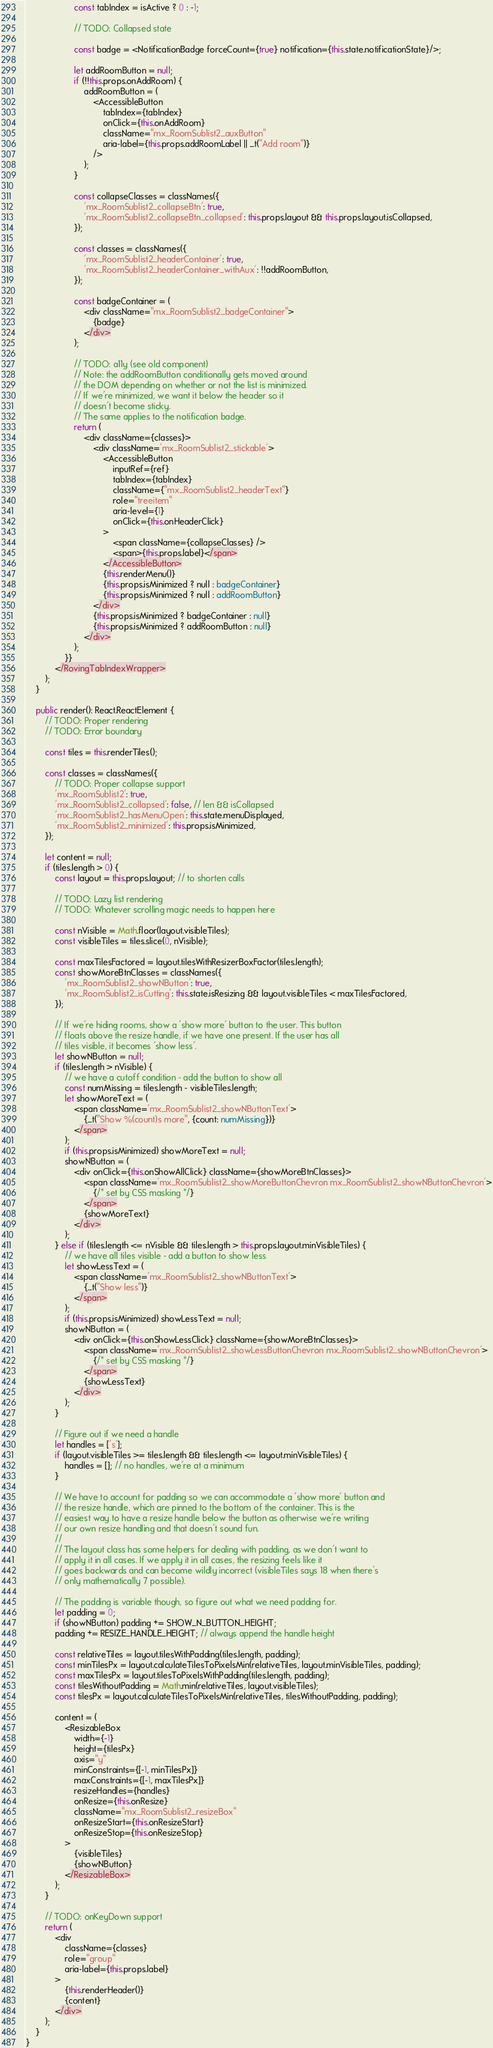Convert code to text. <code><loc_0><loc_0><loc_500><loc_500><_TypeScript_>                    const tabIndex = isActive ? 0 : -1;

                    // TODO: Collapsed state

                    const badge = <NotificationBadge forceCount={true} notification={this.state.notificationState}/>;

                    let addRoomButton = null;
                    if (!!this.props.onAddRoom) {
                        addRoomButton = (
                            <AccessibleButton
                                tabIndex={tabIndex}
                                onClick={this.onAddRoom}
                                className="mx_RoomSublist2_auxButton"
                                aria-label={this.props.addRoomLabel || _t("Add room")}
                            />
                        );
                    }

                    const collapseClasses = classNames({
                        'mx_RoomSublist2_collapseBtn': true,
                        'mx_RoomSublist2_collapseBtn_collapsed': this.props.layout && this.props.layout.isCollapsed,
                    });

                    const classes = classNames({
                        'mx_RoomSublist2_headerContainer': true,
                        'mx_RoomSublist2_headerContainer_withAux': !!addRoomButton,
                    });

                    const badgeContainer = (
                        <div className="mx_RoomSublist2_badgeContainer">
                            {badge}
                        </div>
                    );

                    // TODO: a11y (see old component)
                    // Note: the addRoomButton conditionally gets moved around
                    // the DOM depending on whether or not the list is minimized.
                    // If we're minimized, we want it below the header so it
                    // doesn't become sticky.
                    // The same applies to the notification badge.
                    return (
                        <div className={classes}>
                            <div className='mx_RoomSublist2_stickable'>
                                <AccessibleButton
                                    inputRef={ref}
                                    tabIndex={tabIndex}
                                    className={"mx_RoomSublist2_headerText"}
                                    role="treeitem"
                                    aria-level={1}
                                    onClick={this.onHeaderClick}
                                >
                                    <span className={collapseClasses} />
                                    <span>{this.props.label}</span>
                                </AccessibleButton>
                                {this.renderMenu()}
                                {this.props.isMinimized ? null : badgeContainer}
                                {this.props.isMinimized ? null : addRoomButton}
                            </div>
                            {this.props.isMinimized ? badgeContainer : null}
                            {this.props.isMinimized ? addRoomButton : null}
                        </div>
                    );
                }}
            </RovingTabIndexWrapper>
        );
    }

    public render(): React.ReactElement {
        // TODO: Proper rendering
        // TODO: Error boundary

        const tiles = this.renderTiles();

        const classes = classNames({
            // TODO: Proper collapse support
            'mx_RoomSublist2': true,
            'mx_RoomSublist2_collapsed': false, // len && isCollapsed
            'mx_RoomSublist2_hasMenuOpen': this.state.menuDisplayed,
            'mx_RoomSublist2_minimized': this.props.isMinimized,
        });

        let content = null;
        if (tiles.length > 0) {
            const layout = this.props.layout; // to shorten calls

            // TODO: Lazy list rendering
            // TODO: Whatever scrolling magic needs to happen here

            const nVisible = Math.floor(layout.visibleTiles);
            const visibleTiles = tiles.slice(0, nVisible);

            const maxTilesFactored = layout.tilesWithResizerBoxFactor(tiles.length);
            const showMoreBtnClasses = classNames({
                'mx_RoomSublist2_showNButton': true,
                'mx_RoomSublist2_isCutting': this.state.isResizing && layout.visibleTiles < maxTilesFactored,
            });

            // If we're hiding rooms, show a 'show more' button to the user. This button
            // floats above the resize handle, if we have one present. If the user has all
            // tiles visible, it becomes 'show less'.
            let showNButton = null;
            if (tiles.length > nVisible) {
                // we have a cutoff condition - add the button to show all
                const numMissing = tiles.length - visibleTiles.length;
                let showMoreText = (
                    <span className='mx_RoomSublist2_showNButtonText'>
                        {_t("Show %(count)s more", {count: numMissing})}
                    </span>
                );
                if (this.props.isMinimized) showMoreText = null;
                showNButton = (
                    <div onClick={this.onShowAllClick} className={showMoreBtnClasses}>
                        <span className='mx_RoomSublist2_showMoreButtonChevron mx_RoomSublist2_showNButtonChevron'>
                            {/* set by CSS masking */}
                        </span>
                        {showMoreText}
                    </div>
                );
            } else if (tiles.length <= nVisible && tiles.length > this.props.layout.minVisibleTiles) {
                // we have all tiles visible - add a button to show less
                let showLessText = (
                    <span className='mx_RoomSublist2_showNButtonText'>
                        {_t("Show less")}
                    </span>
                );
                if (this.props.isMinimized) showLessText = null;
                showNButton = (
                    <div onClick={this.onShowLessClick} className={showMoreBtnClasses}>
                        <span className='mx_RoomSublist2_showLessButtonChevron mx_RoomSublist2_showNButtonChevron'>
                            {/* set by CSS masking */}
                        </span>
                        {showLessText}
                    </div>
                );
            }

            // Figure out if we need a handle
            let handles = ['s'];
            if (layout.visibleTiles >= tiles.length && tiles.length <= layout.minVisibleTiles) {
                handles = []; // no handles, we're at a minimum
            }

            // We have to account for padding so we can accommodate a 'show more' button and
            // the resize handle, which are pinned to the bottom of the container. This is the
            // easiest way to have a resize handle below the button as otherwise we're writing
            // our own resize handling and that doesn't sound fun.
            //
            // The layout class has some helpers for dealing with padding, as we don't want to
            // apply it in all cases. If we apply it in all cases, the resizing feels like it
            // goes backwards and can become wildly incorrect (visibleTiles says 18 when there's
            // only mathematically 7 possible).

            // The padding is variable though, so figure out what we need padding for.
            let padding = 0;
            if (showNButton) padding += SHOW_N_BUTTON_HEIGHT;
            padding += RESIZE_HANDLE_HEIGHT; // always append the handle height

            const relativeTiles = layout.tilesWithPadding(tiles.length, padding);
            const minTilesPx = layout.calculateTilesToPixelsMin(relativeTiles, layout.minVisibleTiles, padding);
            const maxTilesPx = layout.tilesToPixelsWithPadding(tiles.length, padding);
            const tilesWithoutPadding = Math.min(relativeTiles, layout.visibleTiles);
            const tilesPx = layout.calculateTilesToPixelsMin(relativeTiles, tilesWithoutPadding, padding);

            content = (
                <ResizableBox
                    width={-1}
                    height={tilesPx}
                    axis="y"
                    minConstraints={[-1, minTilesPx]}
                    maxConstraints={[-1, maxTilesPx]}
                    resizeHandles={handles}
                    onResize={this.onResize}
                    className="mx_RoomSublist2_resizeBox"
                    onResizeStart={this.onResizeStart}
                    onResizeStop={this.onResizeStop}
                >
                    {visibleTiles}
                    {showNButton}
                </ResizableBox>
            );
        }

        // TODO: onKeyDown support
        return (
            <div
                className={classes}
                role="group"
                aria-label={this.props.label}
            >
                {this.renderHeader()}
                {content}
            </div>
        );
    }
}
</code> 